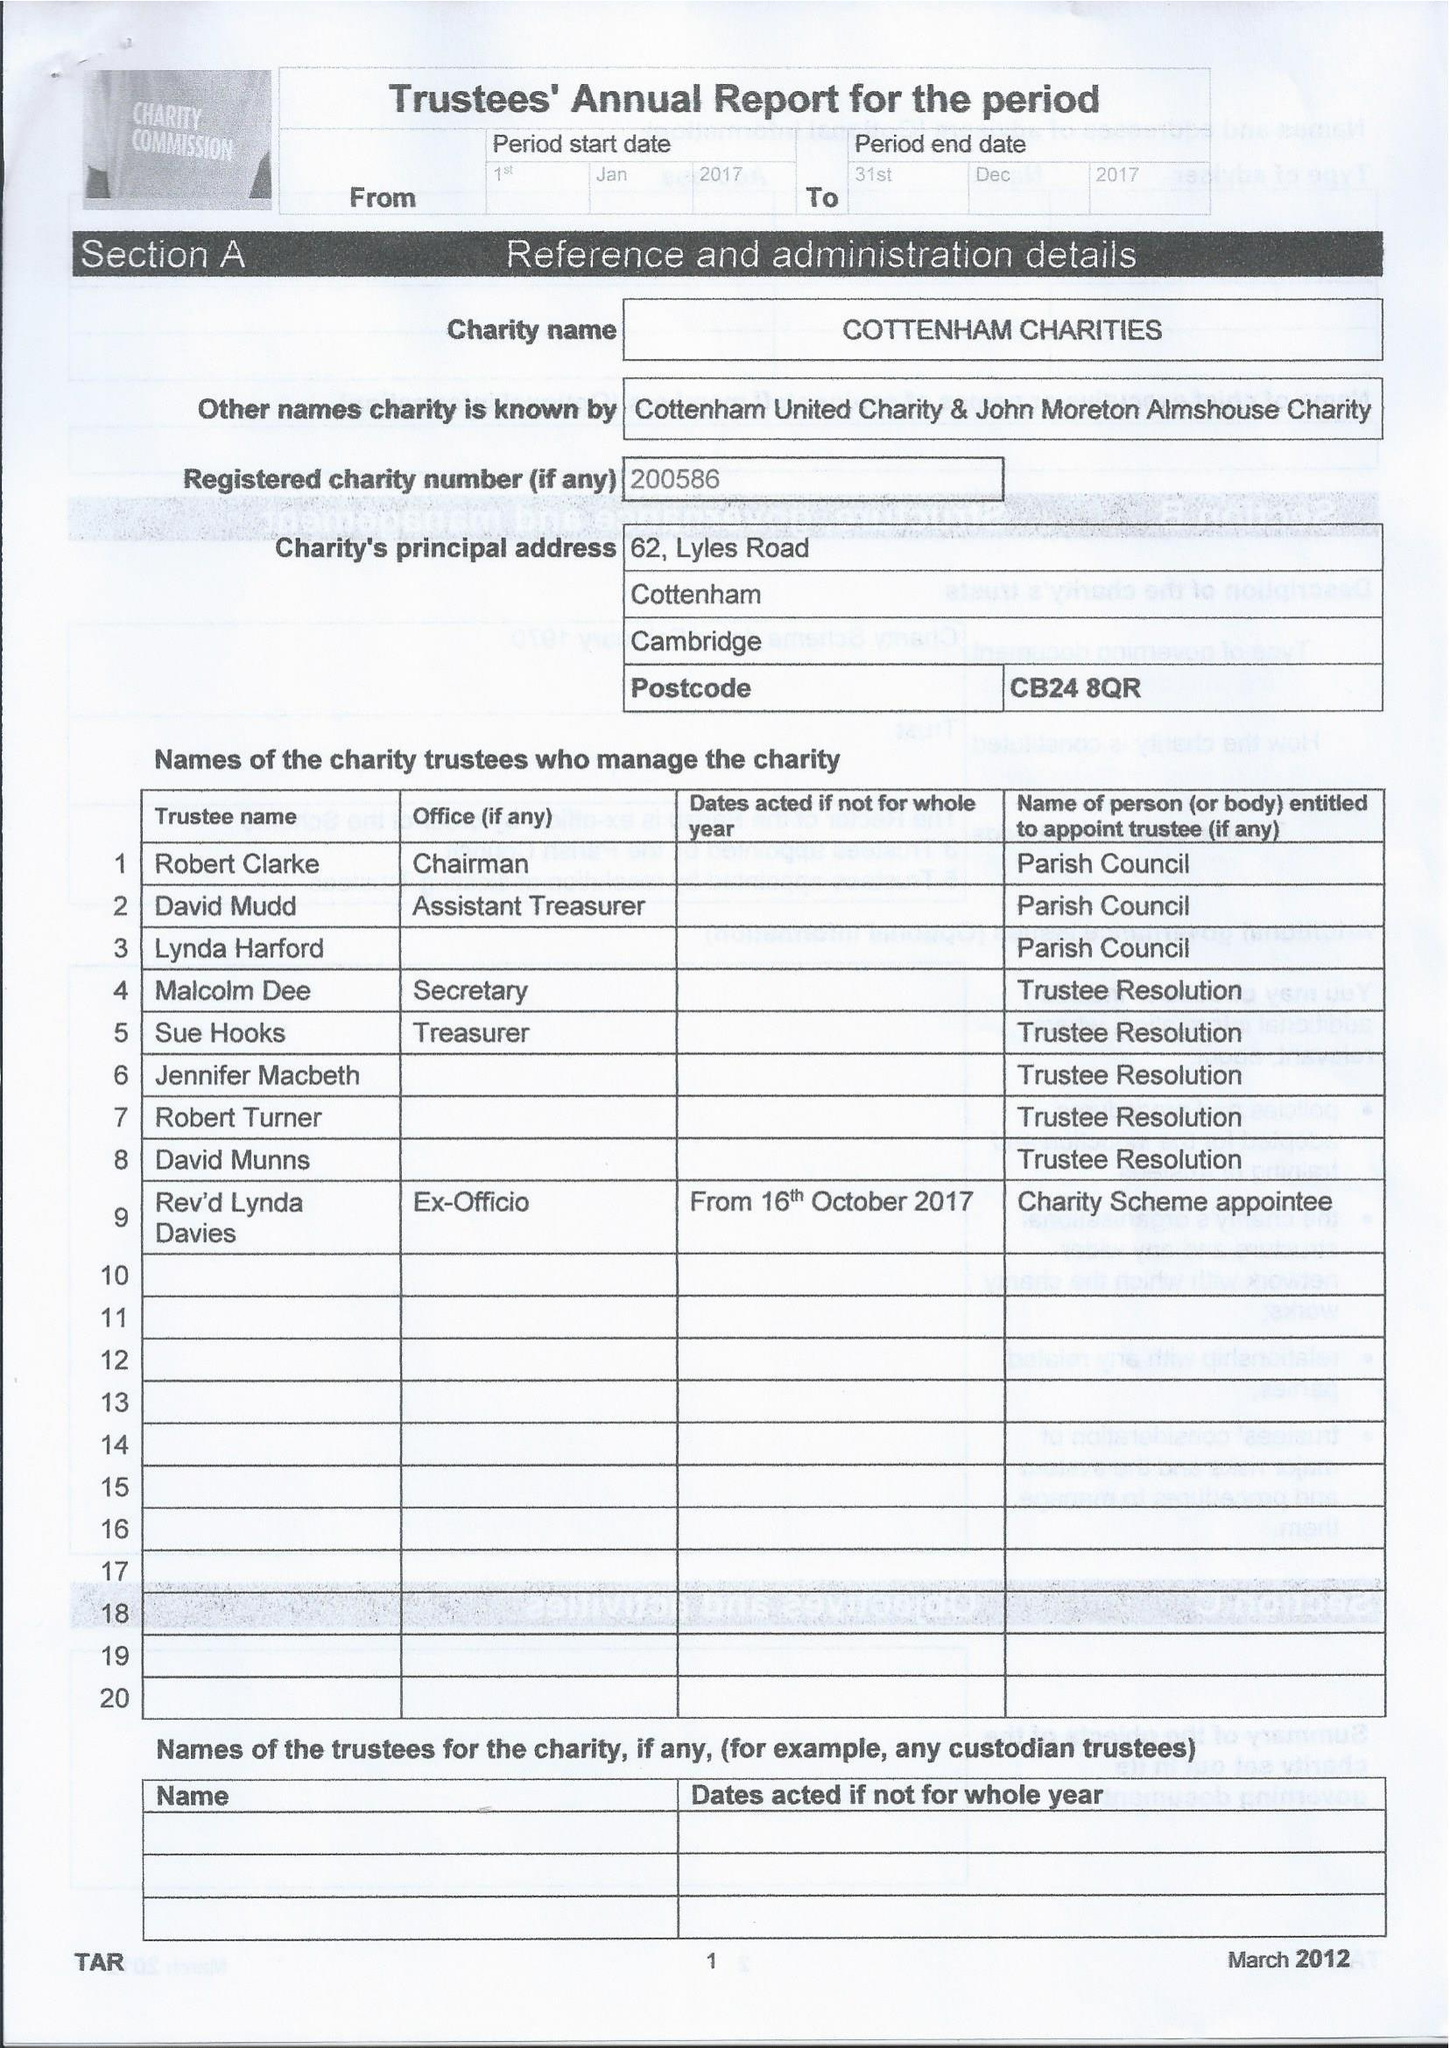What is the value for the address__post_town?
Answer the question using a single word or phrase. CAMBRIDGE 